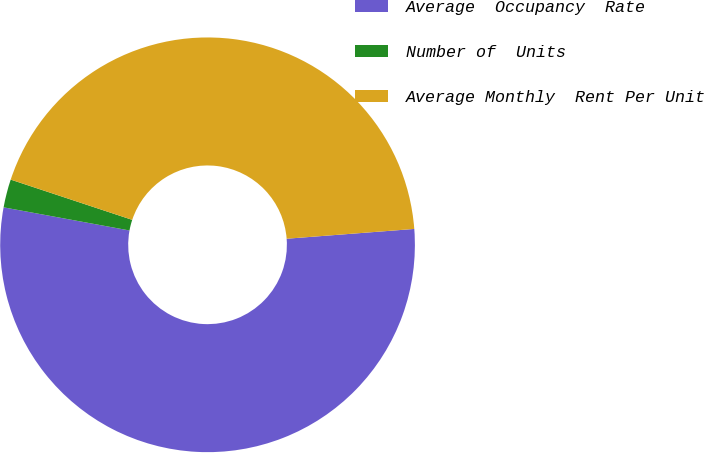Convert chart to OTSL. <chart><loc_0><loc_0><loc_500><loc_500><pie_chart><fcel>Average  Occupancy  Rate<fcel>Number of  Units<fcel>Average Monthly  Rent Per Unit<nl><fcel>54.11%<fcel>2.2%<fcel>43.69%<nl></chart> 